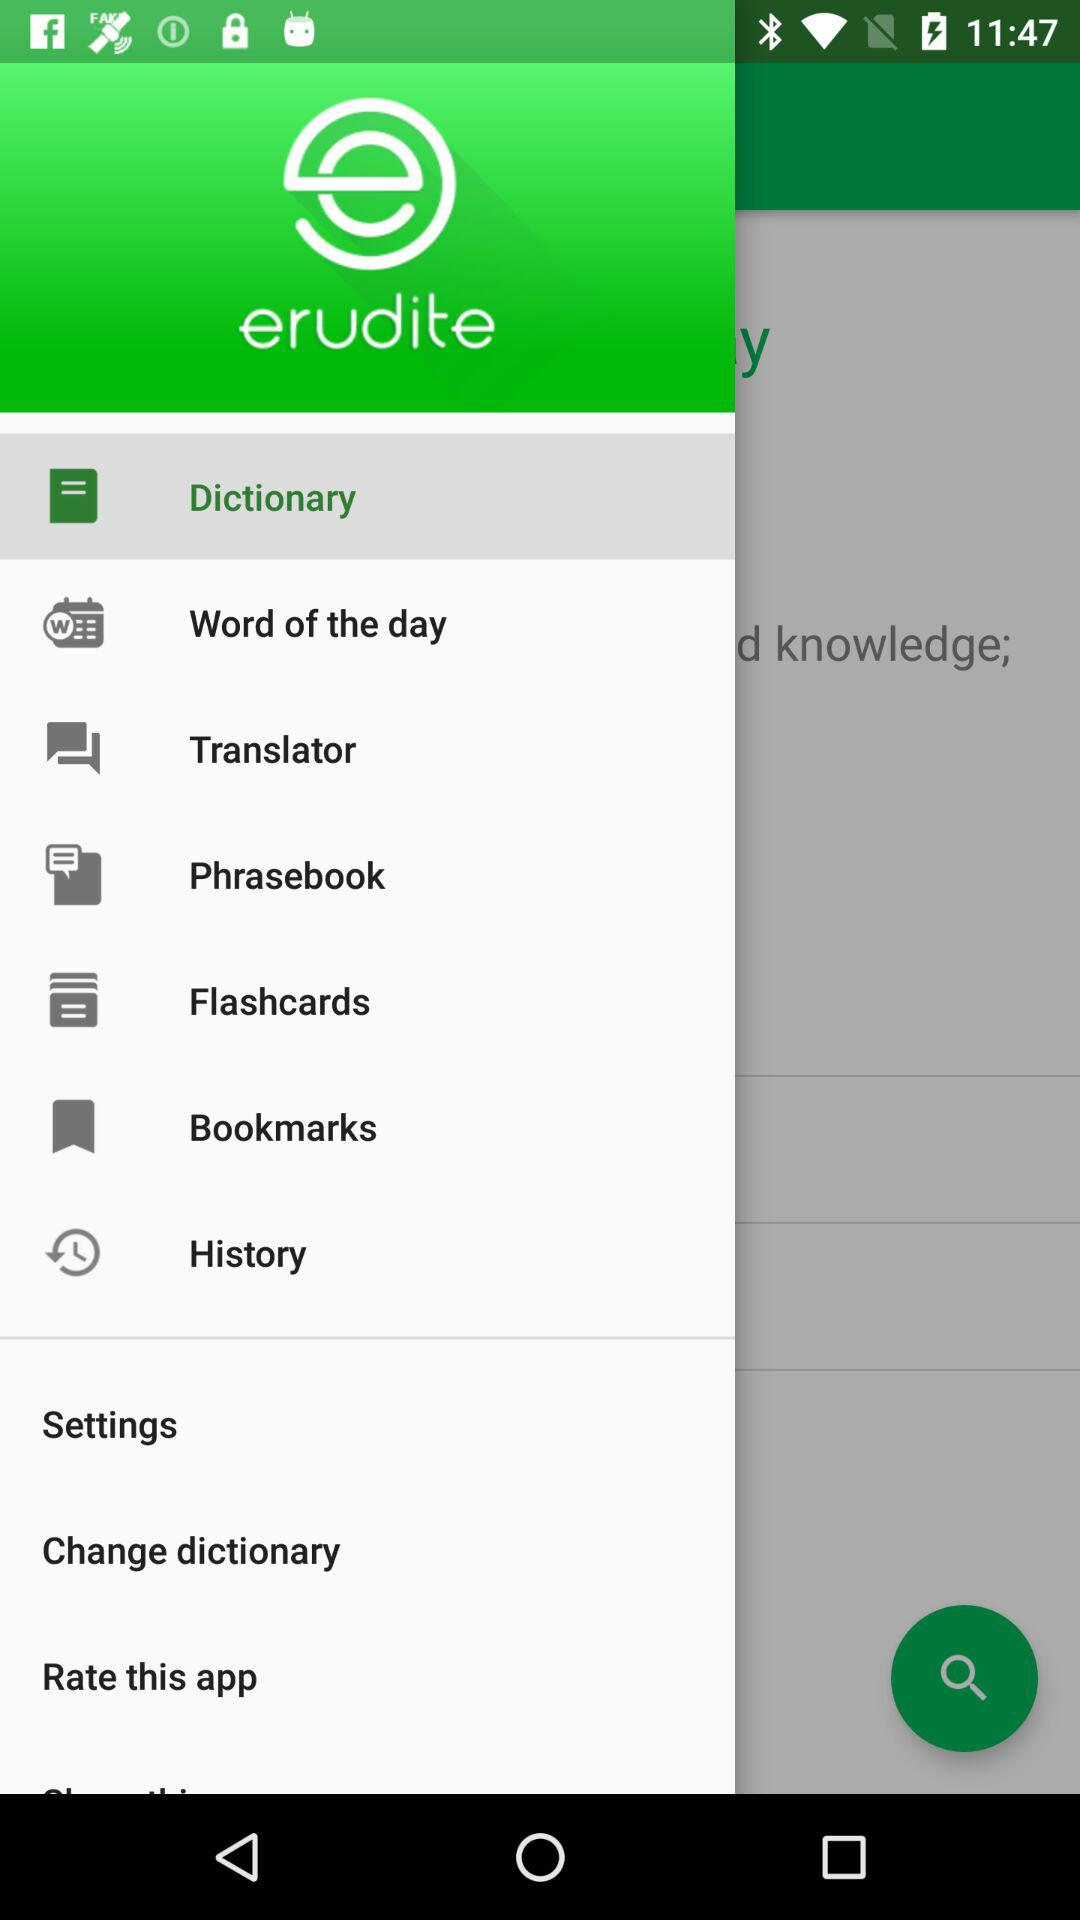What is the name of the application? The name of the application is "erudite". 